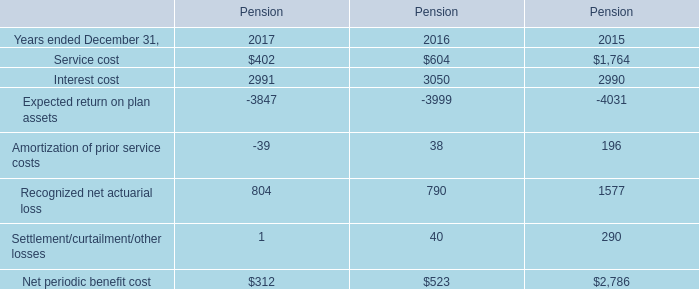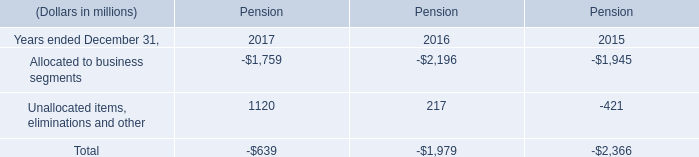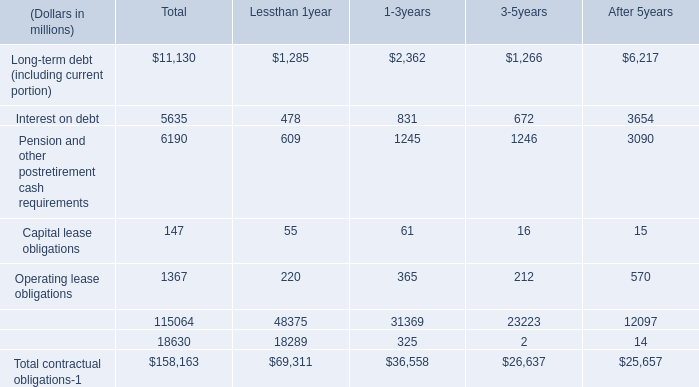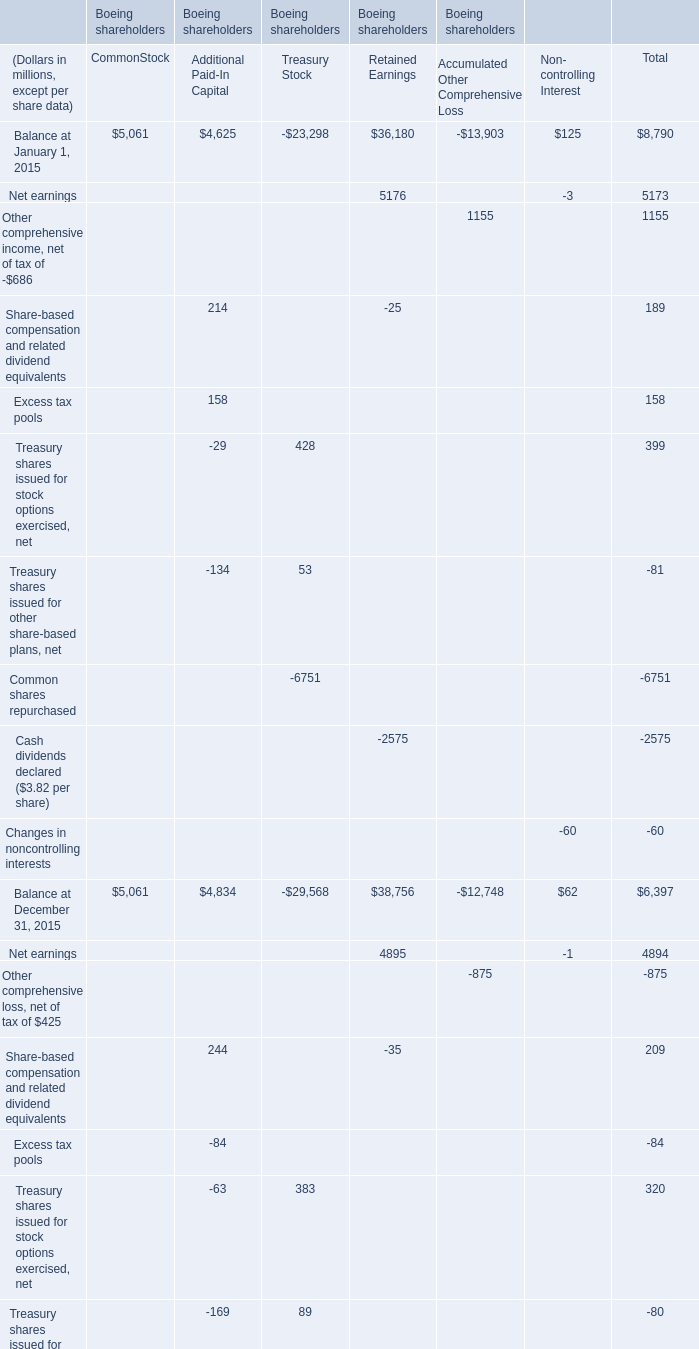approximately what percent of the net gain on hedging in aoci at 12/31/06 is expected to impact net income during 2007? 
Computations: (0.8 / 4)
Answer: 0.2. 